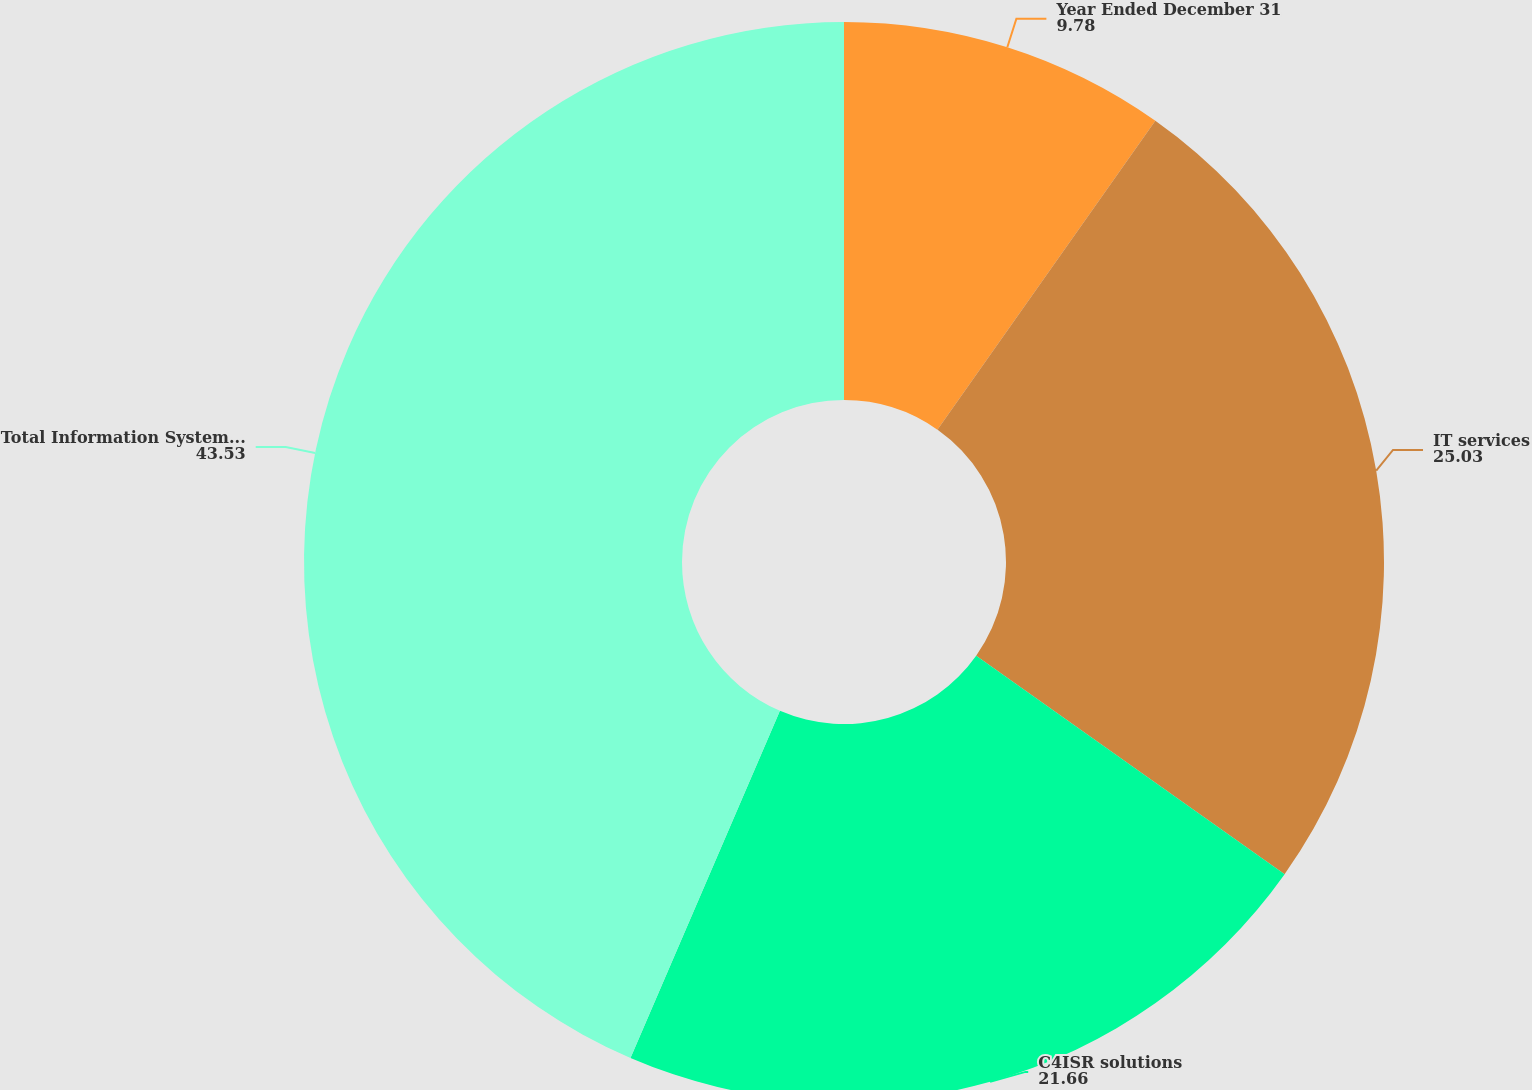Convert chart to OTSL. <chart><loc_0><loc_0><loc_500><loc_500><pie_chart><fcel>Year Ended December 31<fcel>IT services<fcel>C4ISR solutions<fcel>Total Information Systems and<nl><fcel>9.78%<fcel>25.03%<fcel>21.66%<fcel>43.53%<nl></chart> 